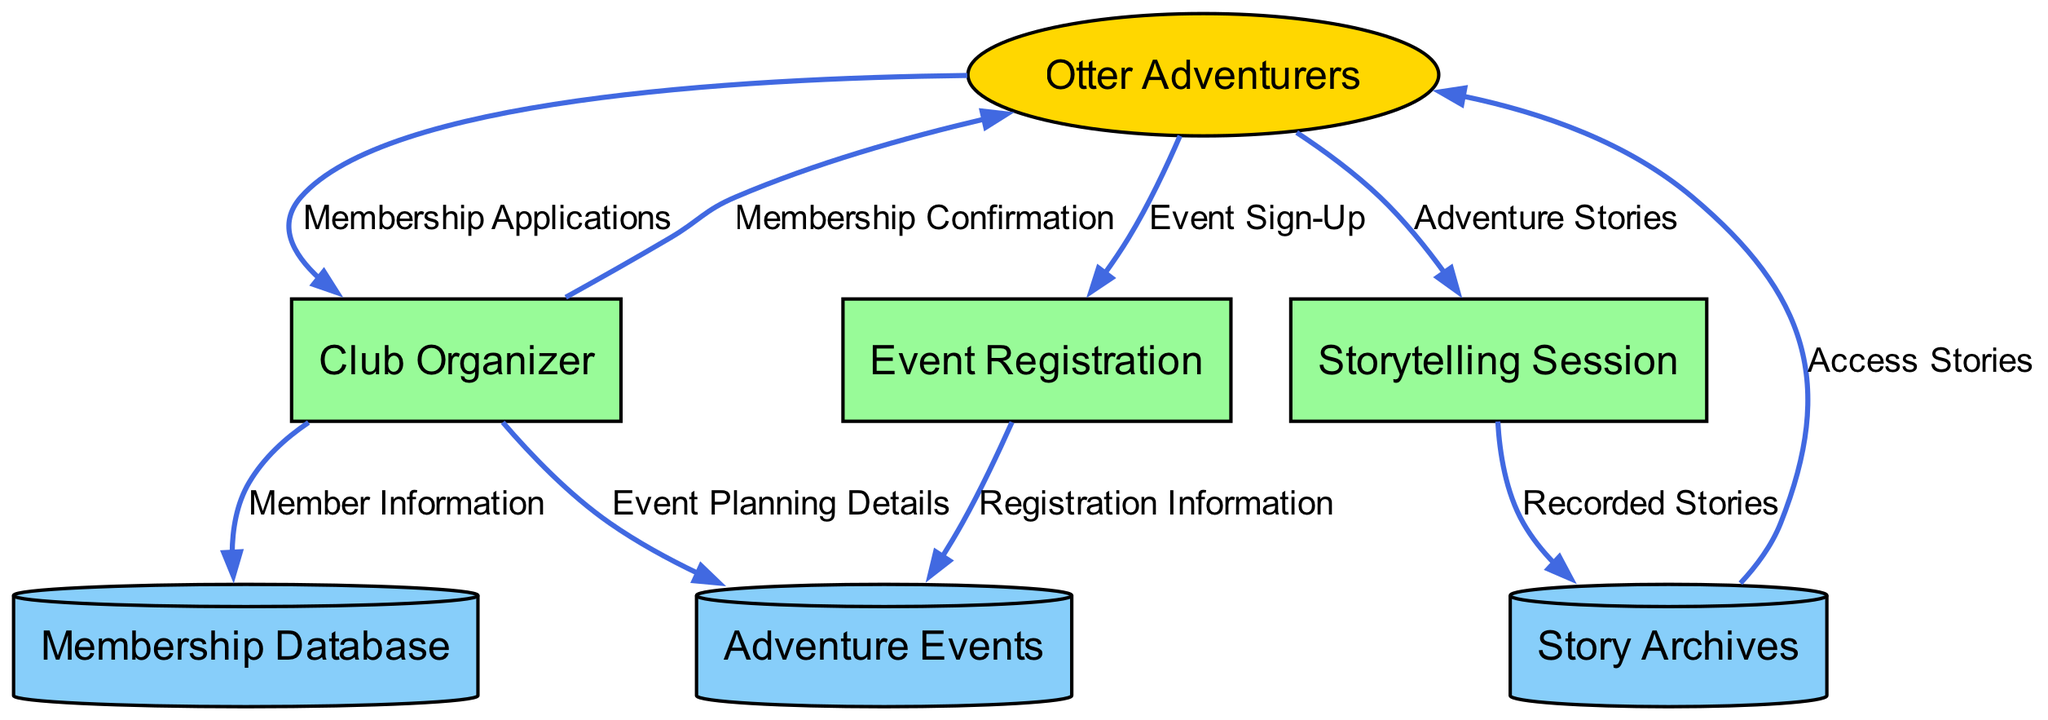What is the external entity in the diagram? The external entity in the diagram is "Otter Adventurers," which represents river otters interested in joining the adventure club.
Answer: Otter Adventurers How many processes are present in the diagram? The diagram contains three processes: "Club Organizer," "Event Registration," and "Storytelling Session." By counting them, we determine that there are three processes.
Answer: 3 What type of data does the "Event Registration" process handle? The "Event Registration" process handles "Event Sign-Up," which refers to the sign-up information provided by members for specific adventure events.
Answer: Event Sign-Up Which data flow originates from the "Storytelling Session"? The data flow that originates from the "Storytelling Session" leads to the "Story Archives" with the data labeled "Recorded Stories," indicating that stories shared during sessions are stored for future reference.
Answer: Recorded Stories What type of relationship exists between "Otter Adventurers" and "Membership Database"? The relationship between "Otter Adventurers" and "Membership Database" is such that "Otter Adventurers" provide "Membership Applications," which are processed by the "Club Organizer," who then stores accepted members' information in the "Membership Database."
Answer: Membership Applications Which external entity receives confirmation after applying for membership? "Otter Adventurers," as they are the ones who apply to join the adventure club and receive "Membership Confirmation" from the "Club Organizer" after their application has been accepted.
Answer: Otter Adventurers What data is stored in the "Story Archives"? The "Story Archives" store "Recorded Stories," which consist of the stories shared by members during the "Storytelling Session." This information is centralized for future access by club members.
Answer: Recorded Stories Which process oversees the planning of adventure events? The "Club Organizer" is the process that oversees the planning of adventure events, providing necessary "Event Planning Details" which are stored in the "Adventure Events" data store.
Answer: Club Organizer How do members access past adventure stories? Members access past adventure stories through the "Story Archives," where they can view "Access Stories." This flow allows them to read archived stories shared by other members.
Answer: Access Stories 